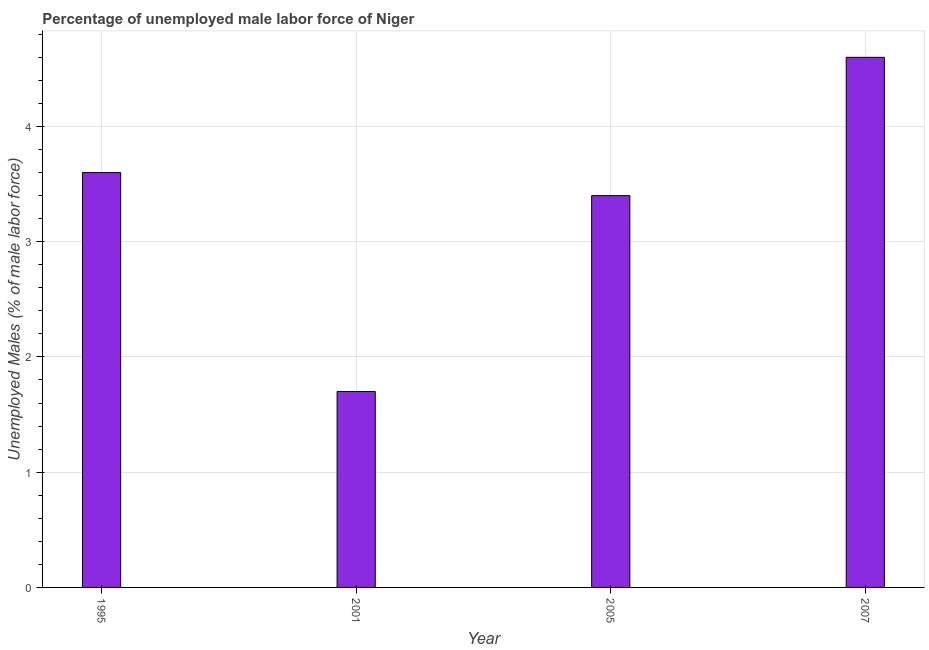What is the title of the graph?
Your response must be concise. Percentage of unemployed male labor force of Niger. What is the label or title of the Y-axis?
Ensure brevity in your answer.  Unemployed Males (% of male labor force). What is the total unemployed male labour force in 2007?
Your answer should be very brief. 4.6. Across all years, what is the maximum total unemployed male labour force?
Your response must be concise. 4.6. Across all years, what is the minimum total unemployed male labour force?
Your answer should be very brief. 1.7. In which year was the total unemployed male labour force maximum?
Your answer should be compact. 2007. In which year was the total unemployed male labour force minimum?
Offer a very short reply. 2001. What is the sum of the total unemployed male labour force?
Offer a very short reply. 13.3. What is the difference between the total unemployed male labour force in 1995 and 2007?
Your answer should be compact. -1. What is the average total unemployed male labour force per year?
Offer a terse response. 3.33. What is the ratio of the total unemployed male labour force in 2005 to that in 2007?
Your answer should be compact. 0.74. What is the difference between the highest and the second highest total unemployed male labour force?
Offer a very short reply. 1. Is the sum of the total unemployed male labour force in 2005 and 2007 greater than the maximum total unemployed male labour force across all years?
Make the answer very short. Yes. What is the difference between the highest and the lowest total unemployed male labour force?
Ensure brevity in your answer.  2.9. In how many years, is the total unemployed male labour force greater than the average total unemployed male labour force taken over all years?
Offer a terse response. 3. How many bars are there?
Offer a very short reply. 4. Are all the bars in the graph horizontal?
Keep it short and to the point. No. What is the Unemployed Males (% of male labor force) of 1995?
Give a very brief answer. 3.6. What is the Unemployed Males (% of male labor force) in 2001?
Provide a short and direct response. 1.7. What is the Unemployed Males (% of male labor force) of 2005?
Keep it short and to the point. 3.4. What is the Unemployed Males (% of male labor force) in 2007?
Your response must be concise. 4.6. What is the difference between the Unemployed Males (% of male labor force) in 1995 and 2001?
Offer a very short reply. 1.9. What is the difference between the Unemployed Males (% of male labor force) in 1995 and 2005?
Give a very brief answer. 0.2. What is the difference between the Unemployed Males (% of male labor force) in 2001 and 2007?
Ensure brevity in your answer.  -2.9. What is the difference between the Unemployed Males (% of male labor force) in 2005 and 2007?
Your response must be concise. -1.2. What is the ratio of the Unemployed Males (% of male labor force) in 1995 to that in 2001?
Your response must be concise. 2.12. What is the ratio of the Unemployed Males (% of male labor force) in 1995 to that in 2005?
Your response must be concise. 1.06. What is the ratio of the Unemployed Males (% of male labor force) in 1995 to that in 2007?
Your response must be concise. 0.78. What is the ratio of the Unemployed Males (% of male labor force) in 2001 to that in 2005?
Keep it short and to the point. 0.5. What is the ratio of the Unemployed Males (% of male labor force) in 2001 to that in 2007?
Ensure brevity in your answer.  0.37. What is the ratio of the Unemployed Males (% of male labor force) in 2005 to that in 2007?
Make the answer very short. 0.74. 